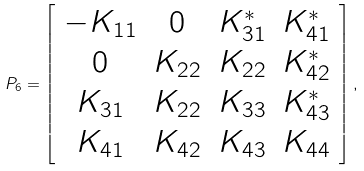Convert formula to latex. <formula><loc_0><loc_0><loc_500><loc_500>P _ { 6 } = \left [ \begin{array} { c c c c } - K _ { 1 1 } & 0 & K _ { 3 1 } ^ { * } & K _ { 4 1 } ^ { * } \\ 0 & K _ { 2 2 } & K _ { 2 2 } & K _ { 4 2 } ^ { * } \\ K _ { 3 1 } & K _ { 2 2 } & K _ { 3 3 } & K _ { 4 3 } ^ { * } \\ K _ { 4 1 } & K _ { 4 2 } & K _ { 4 3 } & K _ { 4 4 } \end{array} \right ] ,</formula> 